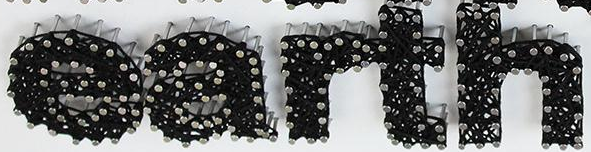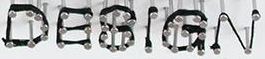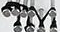What words are shown in these images in order, separated by a semicolon? earth; DESIGN; TM 